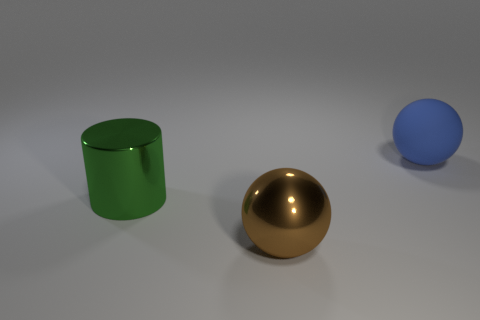Is the big sphere in front of the green object made of the same material as the green thing behind the brown ball?
Provide a succinct answer. Yes. The shiny sphere that is the same size as the blue matte thing is what color?
Your answer should be compact. Brown. There is a metallic thing right of the thing to the left of the big sphere that is left of the matte thing; how big is it?
Make the answer very short. Large. What color is the thing that is both on the right side of the large cylinder and on the left side of the large blue matte ball?
Provide a succinct answer. Brown. What size is the thing to the right of the brown metallic thing?
Your response must be concise. Large. What number of cylinders have the same material as the big brown thing?
Offer a terse response. 1. Does the thing that is to the right of the metallic sphere have the same shape as the large brown metallic object?
Offer a terse response. Yes. There is a large ball that is the same material as the cylinder; what is its color?
Your answer should be compact. Brown. There is a thing on the right side of the large ball that is left of the big blue matte sphere; are there any large things that are in front of it?
Your response must be concise. Yes. The big matte object has what shape?
Your answer should be very brief. Sphere. 